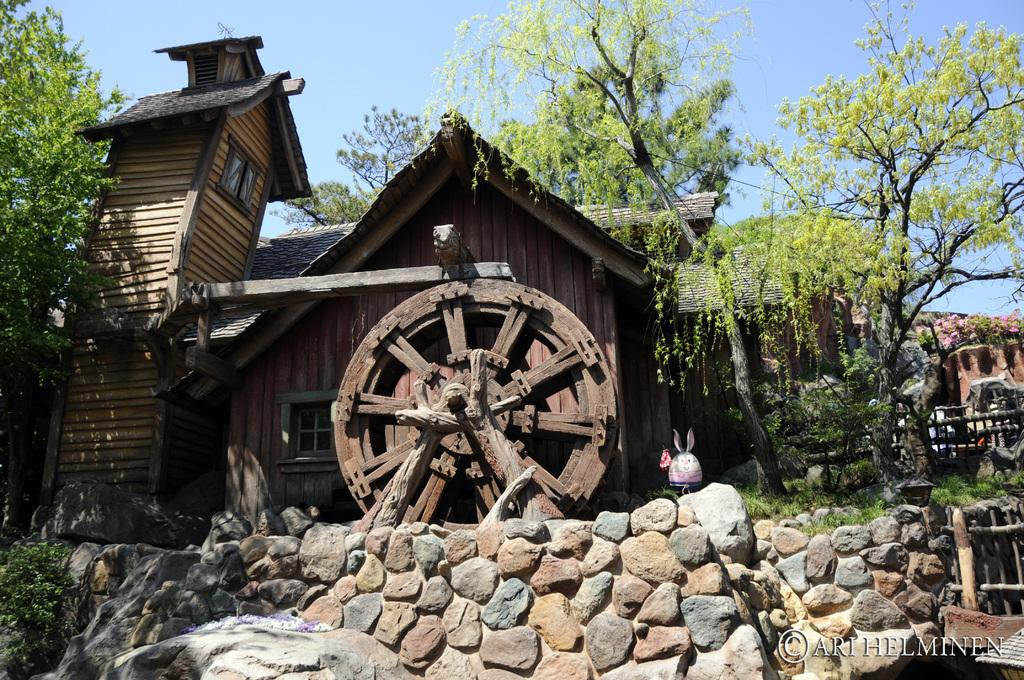What type of structure is visible in the image? There is a house in the image. Can you describe any specific features of the wooden object? The wooden object looks like a wheel. What type of barrier is present in the image? There is a stone wall and a fence in the image. What type of vegetation can be seen in the image? There are trees in the image. What is visible in the background of the image? The sky is visible in the background of the image. How many bells are hanging from the trees in the image? There are no bells present in the image; only a house, a wooden wheel, a stone wall, a fence, trees, and the sky are visible. 